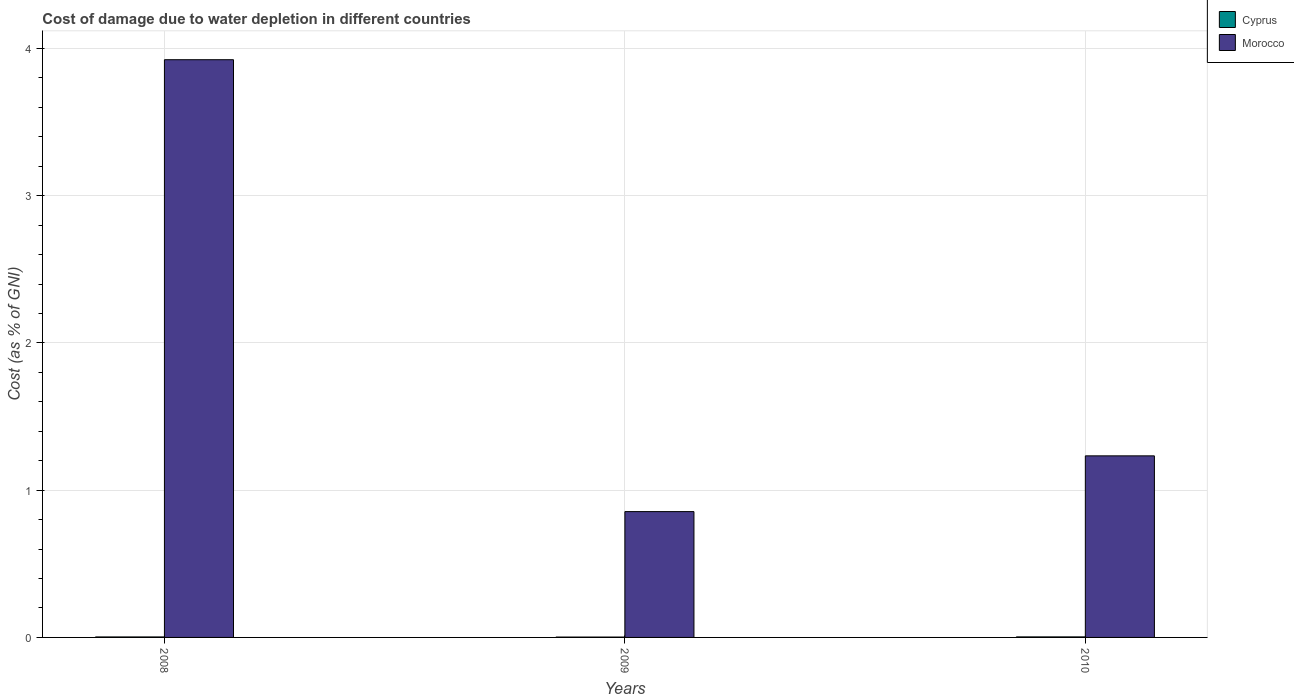How many groups of bars are there?
Make the answer very short. 3. Are the number of bars per tick equal to the number of legend labels?
Offer a terse response. Yes. What is the cost of damage caused due to water depletion in Cyprus in 2010?
Give a very brief answer. 0. Across all years, what is the maximum cost of damage caused due to water depletion in Cyprus?
Keep it short and to the point. 0. Across all years, what is the minimum cost of damage caused due to water depletion in Morocco?
Offer a terse response. 0.85. In which year was the cost of damage caused due to water depletion in Cyprus minimum?
Your answer should be very brief. 2009. What is the total cost of damage caused due to water depletion in Morocco in the graph?
Provide a short and direct response. 6.01. What is the difference between the cost of damage caused due to water depletion in Cyprus in 2008 and that in 2010?
Your answer should be compact. -0. What is the difference between the cost of damage caused due to water depletion in Cyprus in 2010 and the cost of damage caused due to water depletion in Morocco in 2009?
Ensure brevity in your answer.  -0.85. What is the average cost of damage caused due to water depletion in Morocco per year?
Keep it short and to the point. 2. In the year 2010, what is the difference between the cost of damage caused due to water depletion in Morocco and cost of damage caused due to water depletion in Cyprus?
Provide a short and direct response. 1.23. What is the ratio of the cost of damage caused due to water depletion in Morocco in 2008 to that in 2010?
Offer a very short reply. 3.18. Is the cost of damage caused due to water depletion in Cyprus in 2008 less than that in 2009?
Your answer should be very brief. No. What is the difference between the highest and the second highest cost of damage caused due to water depletion in Cyprus?
Your answer should be compact. 0. What is the difference between the highest and the lowest cost of damage caused due to water depletion in Cyprus?
Provide a succinct answer. 0. What does the 2nd bar from the left in 2010 represents?
Make the answer very short. Morocco. What does the 1st bar from the right in 2009 represents?
Keep it short and to the point. Morocco. How many years are there in the graph?
Your response must be concise. 3. What is the difference between two consecutive major ticks on the Y-axis?
Your answer should be very brief. 1. Are the values on the major ticks of Y-axis written in scientific E-notation?
Keep it short and to the point. No. Does the graph contain grids?
Keep it short and to the point. Yes. Where does the legend appear in the graph?
Keep it short and to the point. Top right. How many legend labels are there?
Ensure brevity in your answer.  2. What is the title of the graph?
Give a very brief answer. Cost of damage due to water depletion in different countries. What is the label or title of the X-axis?
Keep it short and to the point. Years. What is the label or title of the Y-axis?
Provide a succinct answer. Cost (as % of GNI). What is the Cost (as % of GNI) in Cyprus in 2008?
Keep it short and to the point. 0. What is the Cost (as % of GNI) of Morocco in 2008?
Provide a succinct answer. 3.92. What is the Cost (as % of GNI) in Cyprus in 2009?
Ensure brevity in your answer.  0. What is the Cost (as % of GNI) in Morocco in 2009?
Keep it short and to the point. 0.85. What is the Cost (as % of GNI) in Cyprus in 2010?
Keep it short and to the point. 0. What is the Cost (as % of GNI) in Morocco in 2010?
Provide a succinct answer. 1.23. Across all years, what is the maximum Cost (as % of GNI) of Cyprus?
Give a very brief answer. 0. Across all years, what is the maximum Cost (as % of GNI) in Morocco?
Keep it short and to the point. 3.92. Across all years, what is the minimum Cost (as % of GNI) of Cyprus?
Offer a very short reply. 0. Across all years, what is the minimum Cost (as % of GNI) of Morocco?
Offer a very short reply. 0.85. What is the total Cost (as % of GNI) in Cyprus in the graph?
Give a very brief answer. 0.01. What is the total Cost (as % of GNI) of Morocco in the graph?
Your answer should be very brief. 6.01. What is the difference between the Cost (as % of GNI) of Cyprus in 2008 and that in 2009?
Give a very brief answer. 0. What is the difference between the Cost (as % of GNI) in Morocco in 2008 and that in 2009?
Your response must be concise. 3.07. What is the difference between the Cost (as % of GNI) of Cyprus in 2008 and that in 2010?
Your answer should be compact. -0. What is the difference between the Cost (as % of GNI) of Morocco in 2008 and that in 2010?
Offer a terse response. 2.69. What is the difference between the Cost (as % of GNI) of Cyprus in 2009 and that in 2010?
Ensure brevity in your answer.  -0. What is the difference between the Cost (as % of GNI) in Morocco in 2009 and that in 2010?
Your answer should be compact. -0.38. What is the difference between the Cost (as % of GNI) of Cyprus in 2008 and the Cost (as % of GNI) of Morocco in 2009?
Ensure brevity in your answer.  -0.85. What is the difference between the Cost (as % of GNI) in Cyprus in 2008 and the Cost (as % of GNI) in Morocco in 2010?
Your answer should be very brief. -1.23. What is the difference between the Cost (as % of GNI) in Cyprus in 2009 and the Cost (as % of GNI) in Morocco in 2010?
Keep it short and to the point. -1.23. What is the average Cost (as % of GNI) of Cyprus per year?
Provide a short and direct response. 0. What is the average Cost (as % of GNI) in Morocco per year?
Provide a succinct answer. 2. In the year 2008, what is the difference between the Cost (as % of GNI) in Cyprus and Cost (as % of GNI) in Morocco?
Provide a succinct answer. -3.92. In the year 2009, what is the difference between the Cost (as % of GNI) of Cyprus and Cost (as % of GNI) of Morocco?
Provide a short and direct response. -0.85. In the year 2010, what is the difference between the Cost (as % of GNI) of Cyprus and Cost (as % of GNI) of Morocco?
Your response must be concise. -1.23. What is the ratio of the Cost (as % of GNI) in Cyprus in 2008 to that in 2009?
Provide a short and direct response. 1.37. What is the ratio of the Cost (as % of GNI) in Morocco in 2008 to that in 2009?
Offer a terse response. 4.59. What is the ratio of the Cost (as % of GNI) in Cyprus in 2008 to that in 2010?
Keep it short and to the point. 0.91. What is the ratio of the Cost (as % of GNI) of Morocco in 2008 to that in 2010?
Make the answer very short. 3.18. What is the ratio of the Cost (as % of GNI) in Cyprus in 2009 to that in 2010?
Make the answer very short. 0.66. What is the ratio of the Cost (as % of GNI) of Morocco in 2009 to that in 2010?
Your response must be concise. 0.69. What is the difference between the highest and the second highest Cost (as % of GNI) of Cyprus?
Ensure brevity in your answer.  0. What is the difference between the highest and the second highest Cost (as % of GNI) of Morocco?
Make the answer very short. 2.69. What is the difference between the highest and the lowest Cost (as % of GNI) of Cyprus?
Give a very brief answer. 0. What is the difference between the highest and the lowest Cost (as % of GNI) of Morocco?
Provide a succinct answer. 3.07. 